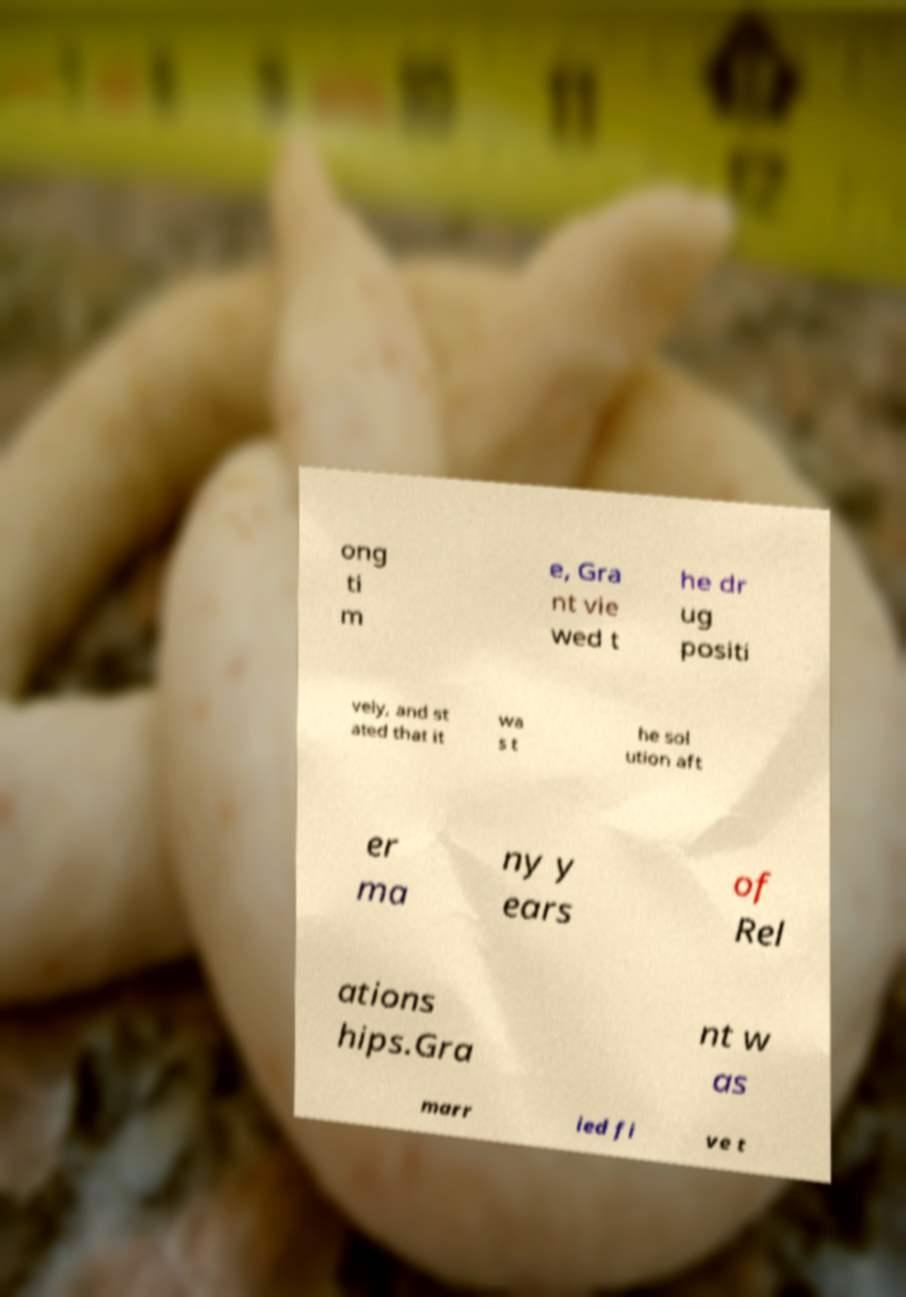Please identify and transcribe the text found in this image. ong ti m e, Gra nt vie wed t he dr ug positi vely, and st ated that it wa s t he sol ution aft er ma ny y ears of Rel ations hips.Gra nt w as marr ied fi ve t 